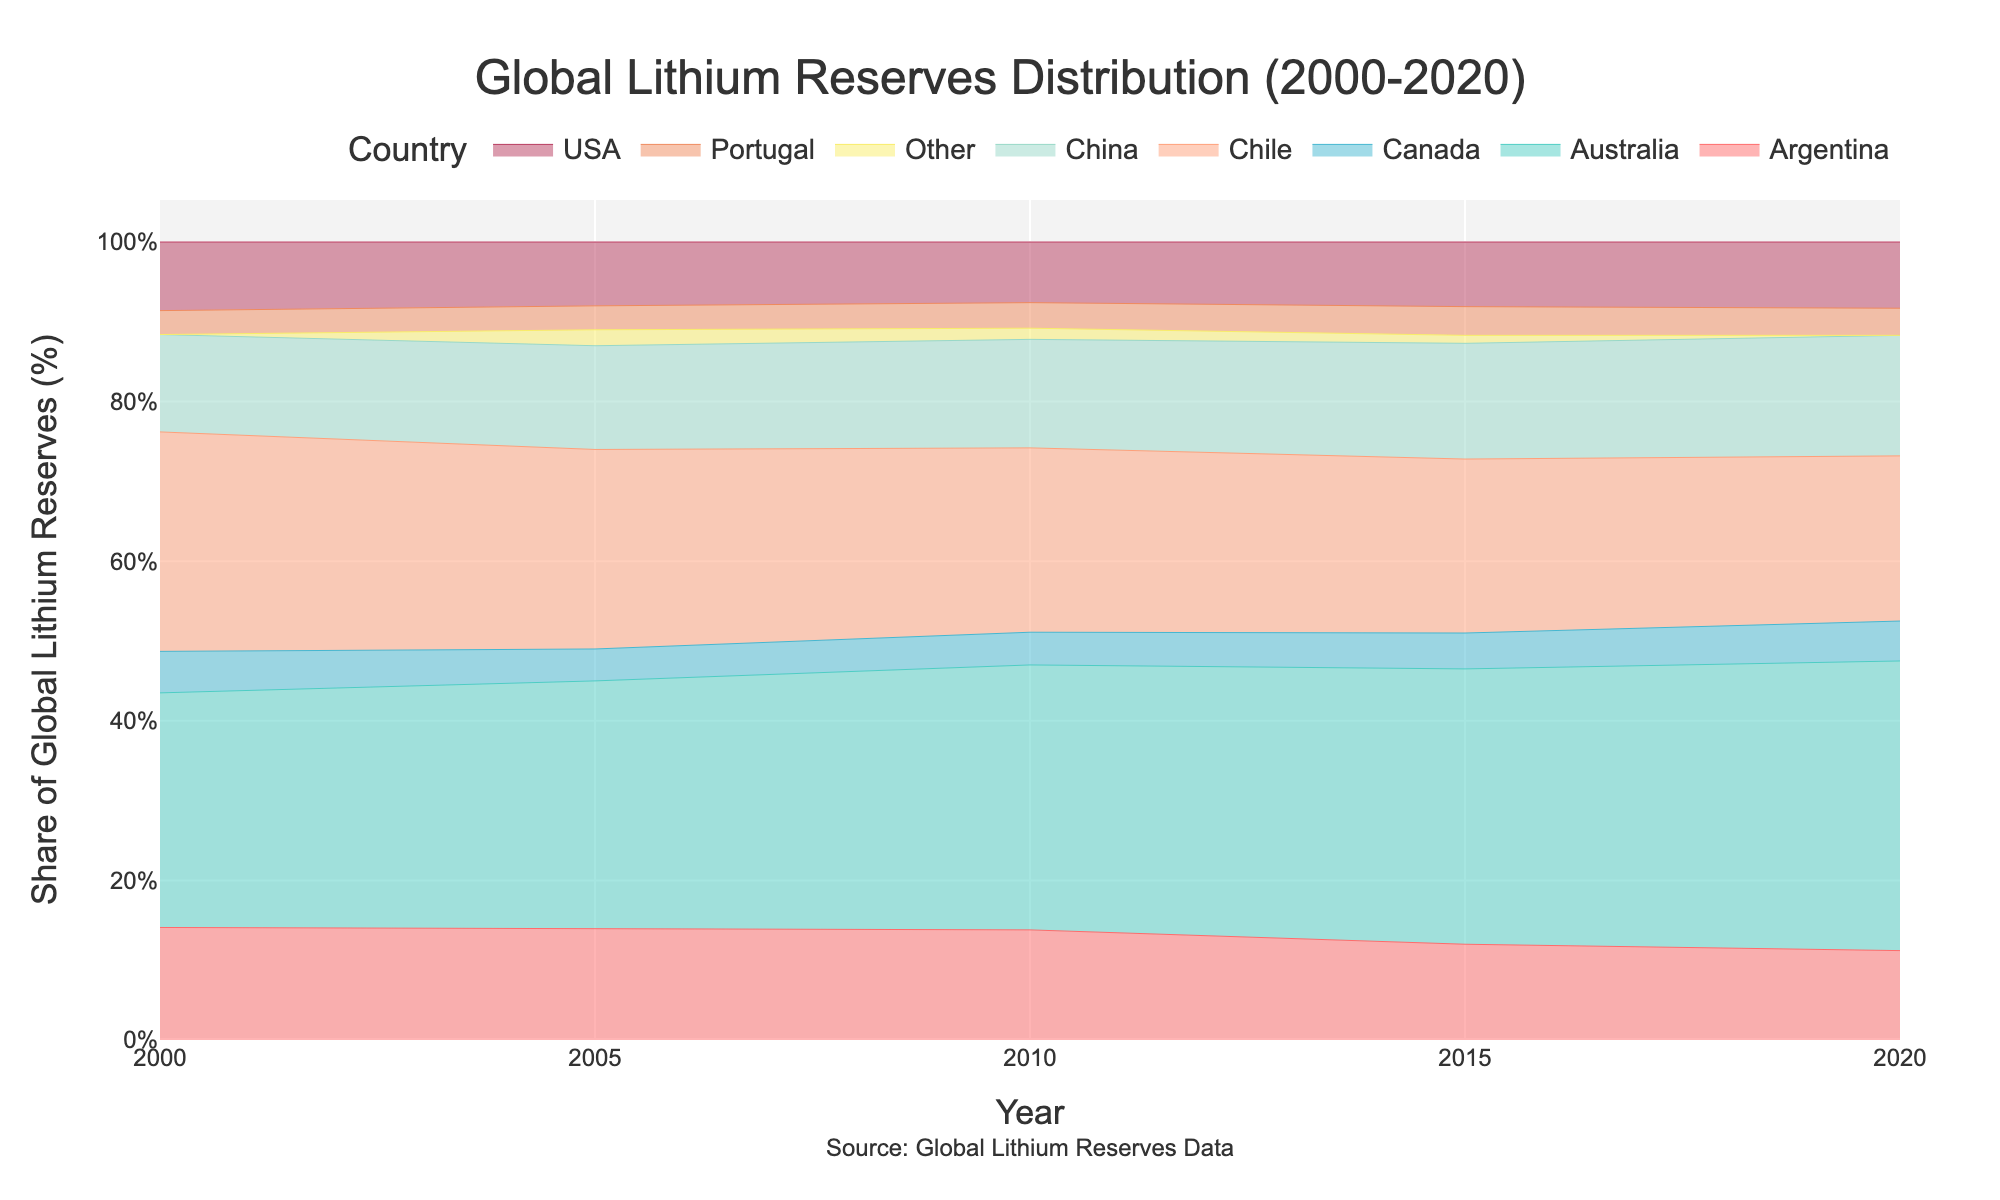What is the title of the plot? The title of the plot is located at the top of the figure and reads "Global Lithium Reserves Distribution (2000-2020)".
Answer: Global Lithium Reserves Distribution (2000-2020) Which country had the highest share of global lithium reserves in 2020? By looking at the topmost color band (representing the country with the largest share) in 2020, we can see it is Australia.
Answer: Australia By how much did Australia's share of global lithium reserves increase from 2000 to 2020? Australia's share increased from 29.4% in 2000 to 36.3% in 2020. The difference is 36.3 - 29.4.
Answer: 6.9% What was the trend for Chile's share of global lithium reserves from 2000 to 2020? Evaluating Chile's share, it decreases each time period: 27.5% in 2000, 25.0% in 2005, 23.1% in 2010, 21.8% in 2015, and finally 20.7% in 2020.
Answer: Decreasing Which two countries had nearly equal shares in 2000 and what were their shares? By checking the stacked areas at the same level in 2000, we find Argentina (14.1%) and China (12.2%) as the closest shares.
Answer: Argentina (14.1%) and China (12.2%) What was the combined share of the USA and Canada in 2010? The share in 2010 for the USA was 7.6% and for Canada was 4.1%. Adding these together, 7.6 + 4.1 = 11.7%.
Answer: 11.7% Of all the countries, which one consistently had the smallest share from 2000 to 2020? By comparing all share segments, Portugal has the smallest and consistent share ranging between 3.0% and 3.6%.
Answer: Portugal Which country's share remained stable the most when comparing 2000 and 2020 data percentages? Portugal's share remained relatively stable, ranging from 3.0% in 2000 to 3.4% in 2020.
Answer: Portugal What is the shape and trajectory of China's share over the years 2000 to 2020? China's share started at 12.2% in 2000 and shows a general increase over the years, reaching 15.1% by 2020.
Answer: Increasing How did the share of 'Other' countries change over the time period? Initially, 'Other' had 0.0% share in 2000, reached 2.0% in 2005, then decreased to 1.4% in 2010, and further dropped to 1.0% in 2015, hitting 0.0% again in 2020.
Answer: Fluctuated and then returned to 0% 